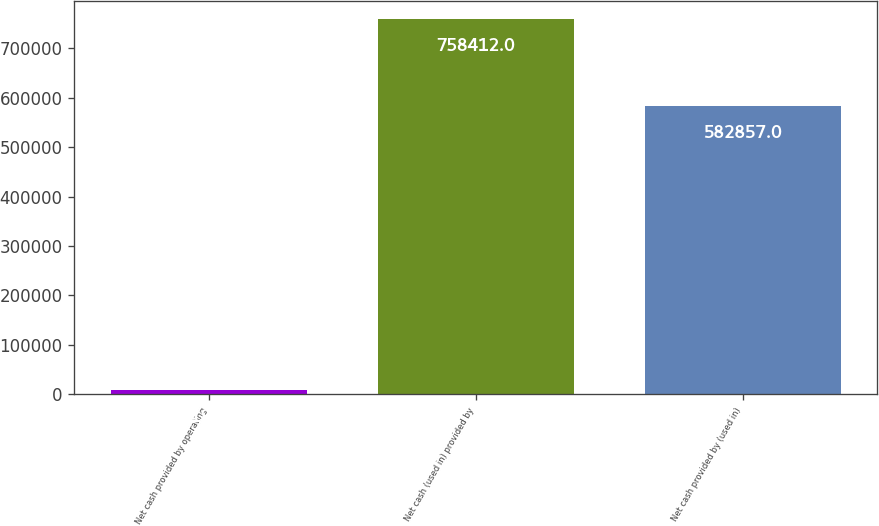<chart> <loc_0><loc_0><loc_500><loc_500><bar_chart><fcel>Net cash provided by operating<fcel>Net cash (used in) provided by<fcel>Net cash provided by (used in)<nl><fcel>8198<fcel>758412<fcel>582857<nl></chart> 